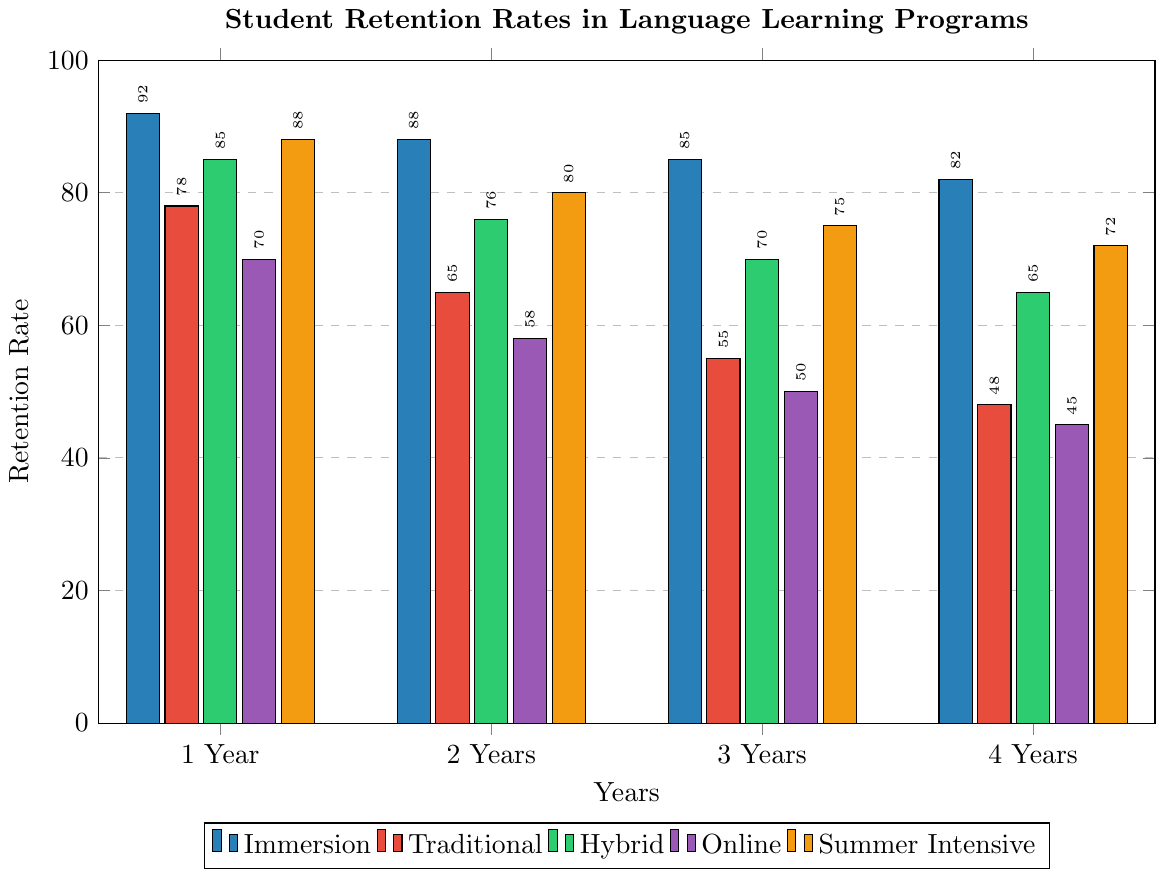Which program has the highest 1 Year Retention rate? By looking at the bars for the 1 Year Retention rates, the Immersion Programs and the Summer Intensive programs both reach up to the highest point, showing a rate of 92% and 88% respectively.
Answer: Immersion Programs What is the difference in 4 Year Retention rates between Immersion Programs and Traditional Language Programs? By looking at the bars for the 4 Year Retention rates, the Immersion Programs have a rate of 82% and the Traditional Language Programs have a rate of 48%. The difference is 82% - 48% = 34%.
Answer: 34% Which program shows the most significant drop in retention from year 1 to year 4? To determine this, we calculate the difference in retention from year 1 to year 4 for each program. For Immersion Programs: 92% - 82% = 10%; Traditional Language Programs: 78% - 48% = 30%; Hybrid Programs: 85% - 65% = 20%; Online Language Programs: 70% - 45% = 25%; Summer Intensive Programs: 88% - 72% = 16%. The Traditional Language Programs have the most significant drop of 30%.
Answer: Traditional Language Programs Which program has a higher 3 Year Retention rate, Hybrid Programs or Online Language Programs? By comparing the bars for the 3 Year Retention rates, the Hybrid Programs have a rate of 70% and the Online Language Programs have a rate of 50%. 70% is higher than 50%.
Answer: Hybrid Programs What is the average retention rate over 4 years for Summer Intensive Programs? To find the average, sum the retention rates over 4 years for Summer Intensive Programs: 88% + 80% + 75% + 72% = 315%. Then divide by 4 years: 315% / 4 = 78.75%.
Answer: 78.75% How much higher is the 2 Year Retention rate for Immersion Programs compared to Online Language Programs? By comparing the bars for 2 Year Retention, Immersion Programs have 88%, and Online Language Programs have 58%. The difference is 88% - 58% = 30%.
Answer: 30% Rank the programs based on their 2 Year Retention rate from highest to lowest. By comparing the heights of the bars for the 2 Year Retention rates:
1. Immersion Programs: 88%
2. Summer Intensive Programs: 80%
3. Hybrid Programs: 76%
4. Traditional Language Programs: 65%
5. Online Language Programs: 58%
Answer: Immersion Programs, Summer Intensive Programs, Hybrid Programs, Traditional Language Programs, Online Language Programs What is the trend in retention rates over 4 years for Hybrid Programs? By looking at the bars representing Hybrid Programs over the 4 years, we see the retention decreases: from 85% (1 Year) to 76% (2 Years) to 70% (3 Years) to 65% (4 Years).
Answer: Decreasing Which color represents Traditional Language Programs? By looking at the legend, the color that matches the Traditional Language Programs is red.
Answer: Red 